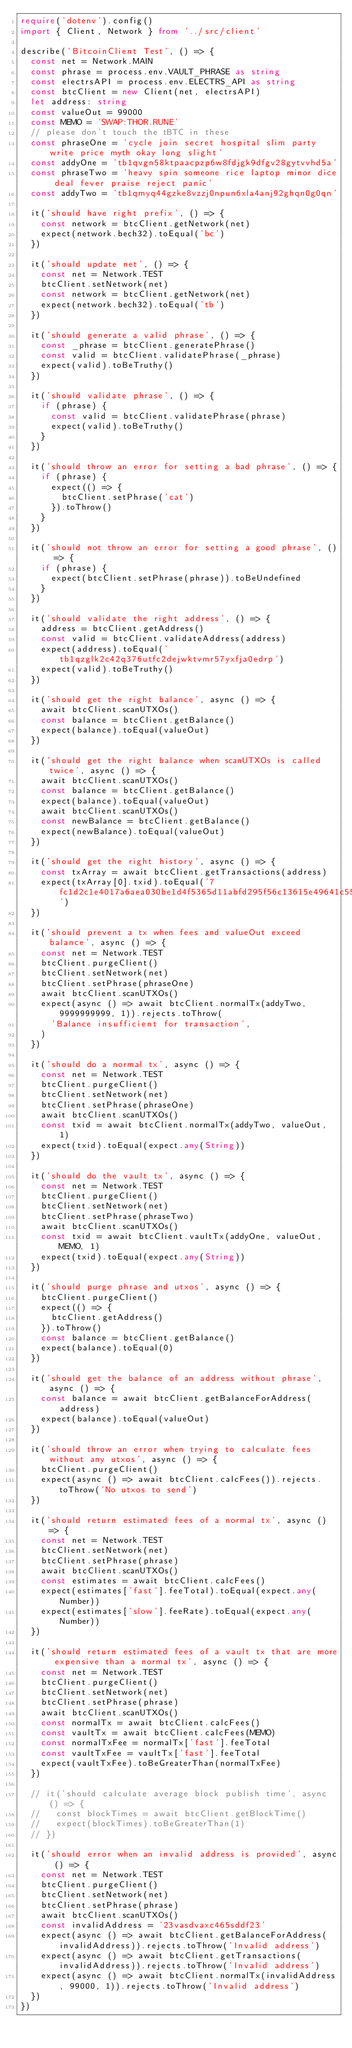Convert code to text. <code><loc_0><loc_0><loc_500><loc_500><_TypeScript_>require('dotenv').config()
import { Client, Network } from '../src/client'

describe('BitcoinClient Test', () => {
  const net = Network.MAIN
  const phrase = process.env.VAULT_PHRASE as string
  const electrsAPI = process.env.ELECTRS_API as string
  const btcClient = new Client(net, electrsAPI)
  let address: string
  const valueOut = 99000
  const MEMO = 'SWAP:THOR.RUNE'
  // please don't touch the tBTC in these
  const phraseOne = 'cycle join secret hospital slim party write price myth okay long slight'
  const addyOne = 'tb1qvgn58ktpaacpzp6w8fdjgk9dfgv28gytvvhd5a'
  const phraseTwo = 'heavy spin someone rice laptop minor dice deal fever praise reject panic'
  const addyTwo = 'tb1qmyq44gzke8vzzj0npun6xla4anj92ghqn0g0qn'

  it('should have right prefix', () => {
    const network = btcClient.getNetwork(net)
    expect(network.bech32).toEqual('bc')
  })

  it('should update net', () => {
    const net = Network.TEST
    btcClient.setNetwork(net)
    const network = btcClient.getNetwork(net)
    expect(network.bech32).toEqual('tb')
  })

  it('should generate a valid phrase', () => {
    const _phrase = btcClient.generatePhrase()
    const valid = btcClient.validatePhrase(_phrase)
    expect(valid).toBeTruthy()
  })

  it('should validate phrase', () => {
    if (phrase) {
      const valid = btcClient.validatePhrase(phrase)
      expect(valid).toBeTruthy()
    }
  })

  it('should throw an error for setting a bad phrase', () => {
    if (phrase) {
      expect(() => {
        btcClient.setPhrase('cat')
      }).toThrow()
    }
  })

  it('should not throw an error for setting a good phrase', () => {
    if (phrase) {
      expect(btcClient.setPhrase(phrase)).toBeUndefined
    }
  })

  it('should validate the right address', () => {
    address = btcClient.getAddress()
    const valid = btcClient.validateAddress(address)
    expect(address).toEqual('tb1qzglk2c42q376utfc2dejwktvmr57yxfja0edrp')
    expect(valid).toBeTruthy()
  })

  it('should get the right balance', async () => {
    await btcClient.scanUTXOs()
    const balance = btcClient.getBalance()
    expect(balance).toEqual(valueOut)
  })

  it('should get the right balance when scanUTXOs is called twice', async () => {
    await btcClient.scanUTXOs()
    const balance = btcClient.getBalance()
    expect(balance).toEqual(valueOut)
    await btcClient.scanUTXOs()
    const newBalance = btcClient.getBalance()
    expect(newBalance).toEqual(valueOut)
  })

  it('should get the right history', async () => {
    const txArray = await btcClient.getTransactions(address)
    expect(txArray[0].txid).toEqual('7fc1d2c1e4017a6aea030be1d4f5365d11abfd295f56c13615e49641c55c54b8')
  })

  it('should prevent a tx when fees and valueOut exceed balance', async () => {
    const net = Network.TEST
    btcClient.purgeClient()
    btcClient.setNetwork(net)
    btcClient.setPhrase(phraseOne)
    await btcClient.scanUTXOs()
    expect(async () => await btcClient.normalTx(addyTwo, 9999999999, 1)).rejects.toThrow(
      'Balance insufficient for transaction',
    )
  })

  it('should do a normal tx', async () => {
    const net = Network.TEST
    btcClient.purgeClient()
    btcClient.setNetwork(net)
    btcClient.setPhrase(phraseOne)
    await btcClient.scanUTXOs()
    const txid = await btcClient.normalTx(addyTwo, valueOut, 1)
    expect(txid).toEqual(expect.any(String))
  })

  it('should do the vault tx', async () => {
    const net = Network.TEST
    btcClient.purgeClient()
    btcClient.setNetwork(net)
    btcClient.setPhrase(phraseTwo)
    await btcClient.scanUTXOs()
    const txid = await btcClient.vaultTx(addyOne, valueOut, MEMO, 1)
    expect(txid).toEqual(expect.any(String))
  })

  it('should purge phrase and utxos', async () => {
    btcClient.purgeClient()
    expect(() => {
      btcClient.getAddress()
    }).toThrow()
    const balance = btcClient.getBalance()
    expect(balance).toEqual(0)
  })

  it('should get the balance of an address without phrase', async () => {
    const balance = await btcClient.getBalanceForAddress(address)
    expect(balance).toEqual(valueOut)
  })

  it('should throw an error when trying to calculate fees without any utxos', async () => {
    btcClient.purgeClient()
    expect(async () => await btcClient.calcFees()).rejects.toThrow('No utxos to send')
  })

  it('should return estimated fees of a normal tx', async () => {
    const net = Network.TEST
    btcClient.setNetwork(net)
    btcClient.setPhrase(phrase)
    await btcClient.scanUTXOs()
    const estimates = await btcClient.calcFees()
    expect(estimates['fast'].feeTotal).toEqual(expect.any(Number))
    expect(estimates['slow'].feeRate).toEqual(expect.any(Number))
  })

  it('should return estimated fees of a vault tx that are more expensive than a normal tx', async () => {
    const net = Network.TEST
    btcClient.purgeClient()
    btcClient.setNetwork(net)
    btcClient.setPhrase(phrase)
    await btcClient.scanUTXOs()
    const normalTx = await btcClient.calcFees()
    const vaultTx = await btcClient.calcFees(MEMO)
    const normalTxFee = normalTx['fast'].feeTotal
    const vaultTxFee = vaultTx['fast'].feeTotal
    expect(vaultTxFee).toBeGreaterThan(normalTxFee)
  })

  // it('should calculate average block publish time', async () => {
  //   const blockTimes = await btcClient.getBlockTime()
  //   expect(blockTimes).toBeGreaterThan(1)
  // })

  it('should error when an invalid address is provided', async () => {
    const net = Network.TEST
    btcClient.purgeClient()
    btcClient.setNetwork(net)
    btcClient.setPhrase(phrase)
    await btcClient.scanUTXOs()
    const invalidAddress = '23vasdvaxc465sddf23'
    expect(async () => await btcClient.getBalanceForAddress(invalidAddress)).rejects.toThrow('Invalid address')
    expect(async () => await btcClient.getTransactions(invalidAddress)).rejects.toThrow('Invalid address')
    expect(async () => await btcClient.normalTx(invalidAddress, 99000, 1)).rejects.toThrow('Invalid address')
  })
})
</code> 